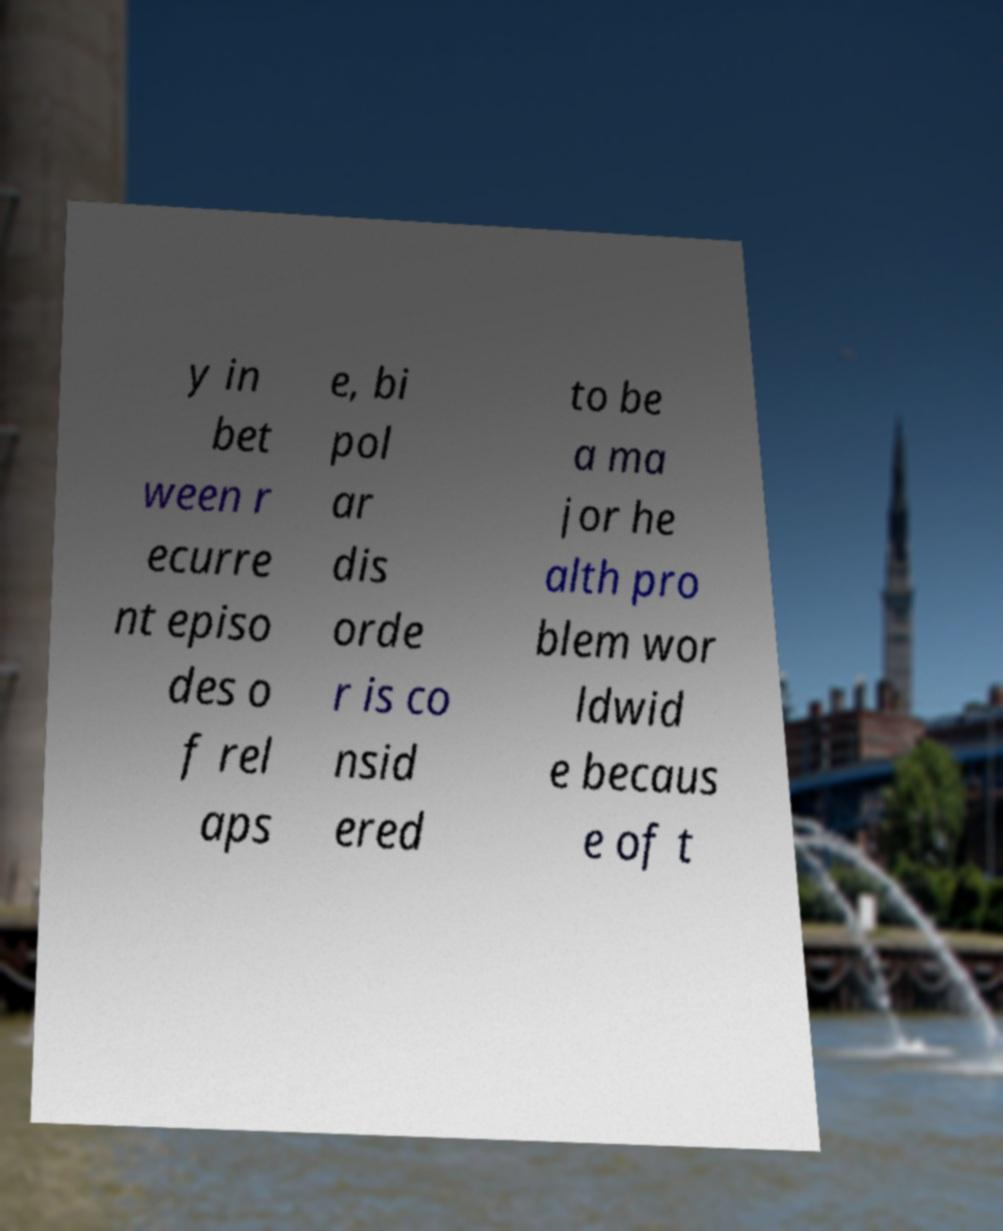Could you assist in decoding the text presented in this image and type it out clearly? y in bet ween r ecurre nt episo des o f rel aps e, bi pol ar dis orde r is co nsid ered to be a ma jor he alth pro blem wor ldwid e becaus e of t 